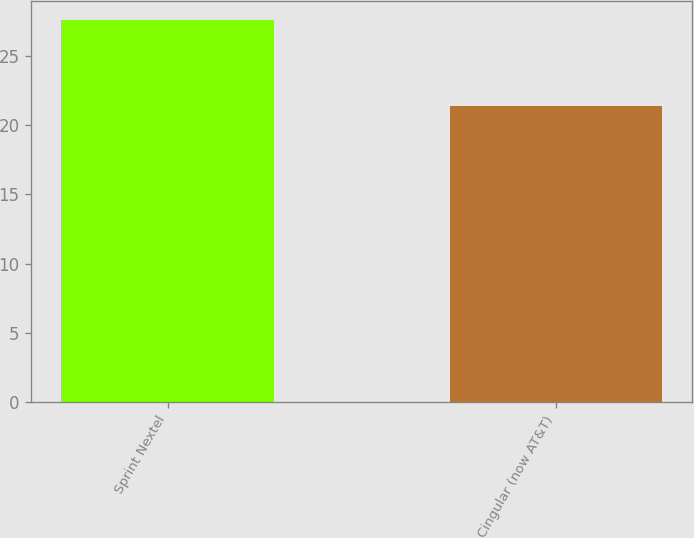Convert chart. <chart><loc_0><loc_0><loc_500><loc_500><bar_chart><fcel>Sprint Nextel<fcel>Cingular (now AT&T)<nl><fcel>27.6<fcel>21.4<nl></chart> 